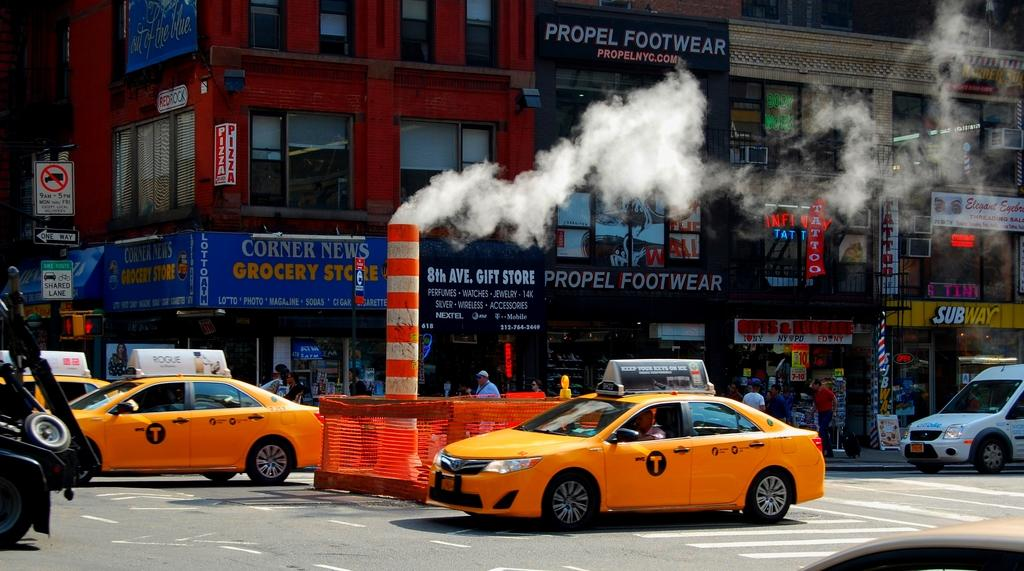Provide a one-sentence caption for the provided image. Yellow cabs are in an intersection in front of a Propel Footwear store. 